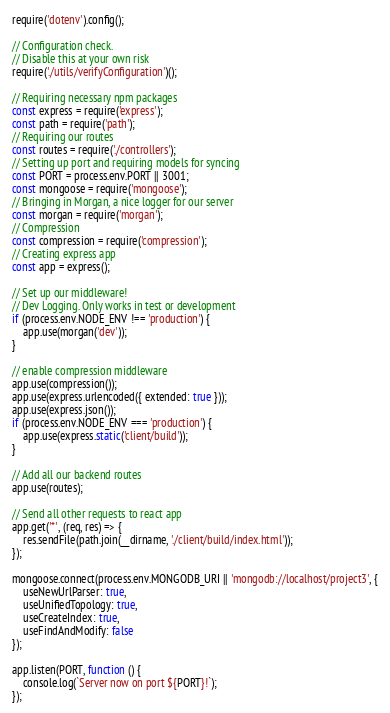<code> <loc_0><loc_0><loc_500><loc_500><_JavaScript_>require('dotenv').config();

// Configuration check.
// Disable this at your own risk
require('./utils/verifyConfiguration')();

// Requiring necessary npm packages
const express = require('express');
const path = require('path');
// Requiring our routes
const routes = require('./controllers');
// Setting up port and requiring models for syncing
const PORT = process.env.PORT || 3001;
const mongoose = require('mongoose');
// Bringing in Morgan, a nice logger for our server
const morgan = require('morgan');
// Compression
const compression = require('compression');
// Creating express app
const app = express();

// Set up our middleware!
// Dev Logging. Only works in test or development
if (process.env.NODE_ENV !== 'production') {
    app.use(morgan('dev'));
}

// enable compression middleware
app.use(compression());
app.use(express.urlencoded({ extended: true }));
app.use(express.json());
if (process.env.NODE_ENV === 'production') {
    app.use(express.static('client/build'));
}

// Add all our backend routes
app.use(routes);

// Send all other requests to react app
app.get('*', (req, res) => {
    res.sendFile(path.join(__dirname, './client/build/index.html'));
});

mongoose.connect(process.env.MONGODB_URI || 'mongodb://localhost/project3', {
    useNewUrlParser: true,
    useUnifiedTopology: true,
    useCreateIndex: true,
    useFindAndModify: false
});

app.listen(PORT, function () {
    console.log(`Server now on port ${PORT}!`);
});

</code> 